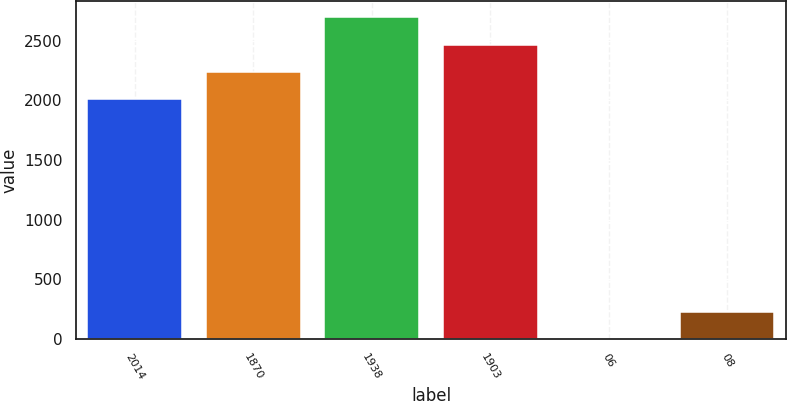Convert chart to OTSL. <chart><loc_0><loc_0><loc_500><loc_500><bar_chart><fcel>2014<fcel>1870<fcel>1938<fcel>1903<fcel>06<fcel>08<nl><fcel>2012<fcel>2239.38<fcel>2694.14<fcel>2466.76<fcel>0.17<fcel>227.55<nl></chart> 